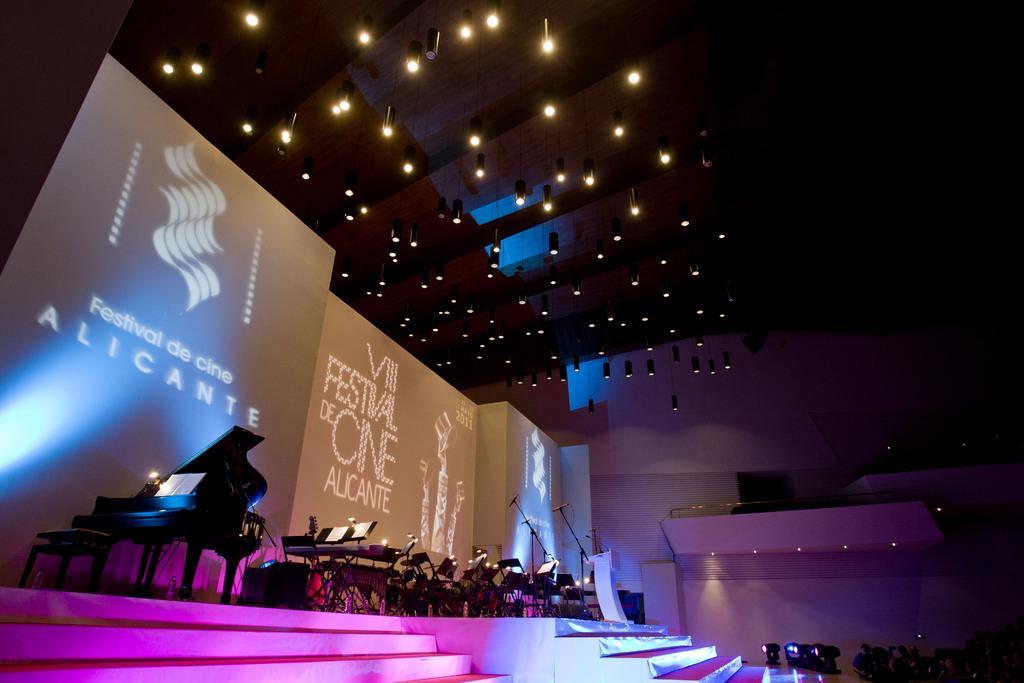Can you describe this image briefly? In this image I can see many musical instruments on the stage. At the back there is a banner and at the top there are many lights. 